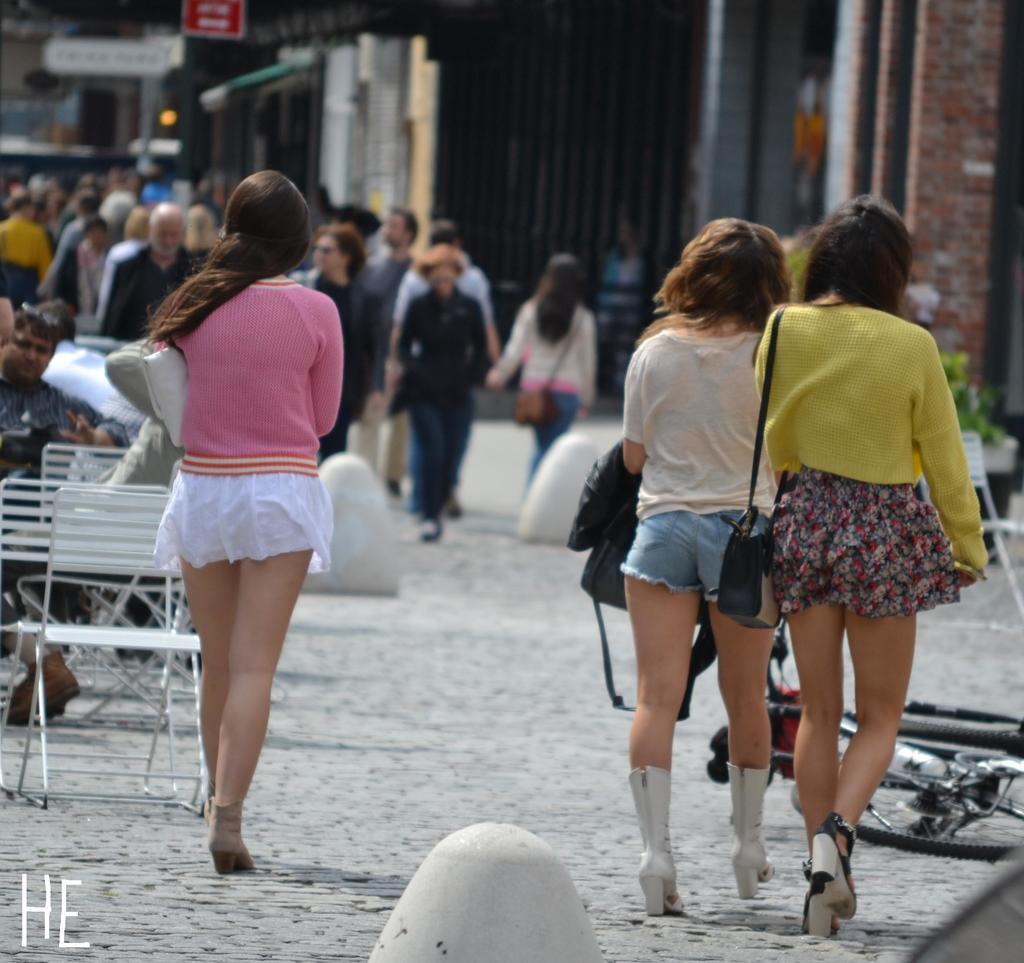Could you give a brief overview of what you see in this image? In the image there are few people standing and they are carrying bags. Behind there are tables and chairs. And also there are many people in the background. And also there is a blur image in the background with buildings and posters. 